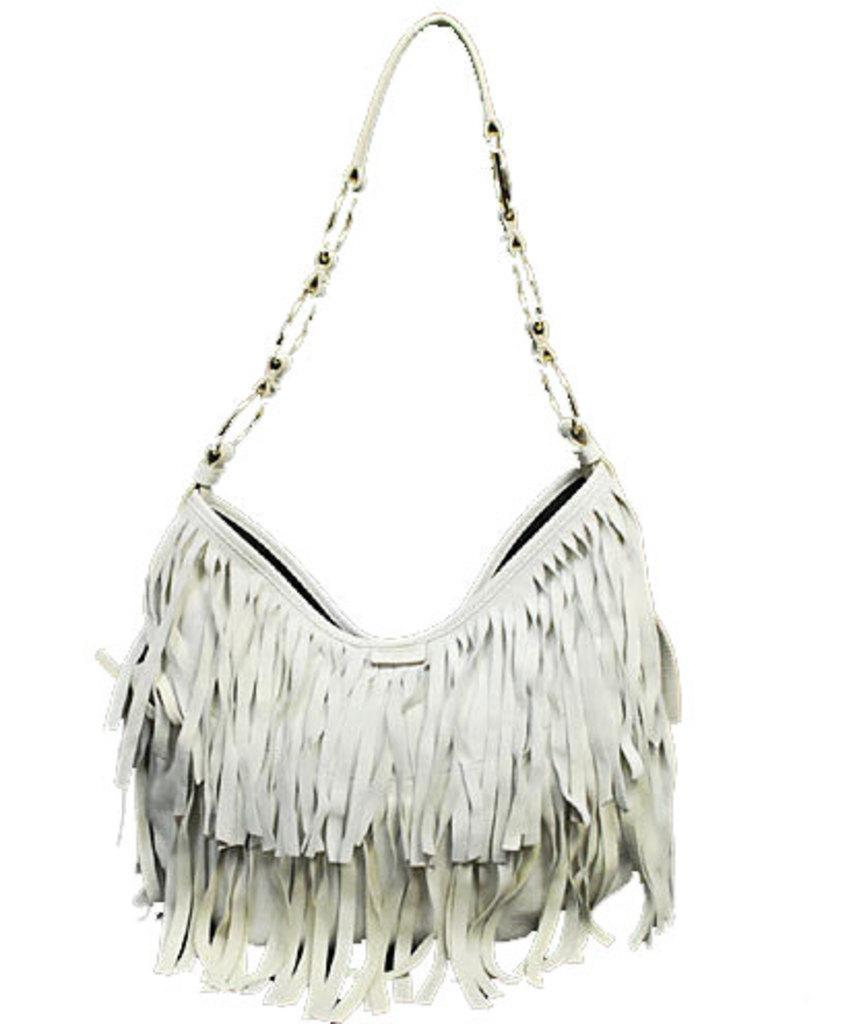What type of accessory is visible in the image? The image contains a woman's handbag. Can you see any feathers sticking out of the handbag in the image? There are no feathers visible in the image; it only features a woman's handbag. What type of activity is the woman engaging in while carrying the handbag in the image? The provided facts do not give any information about the woman's activity or what she is doing in the image. Is the handbag located near a cemetery in the image? There is no information about the location or surroundings of the handbag in the image. 